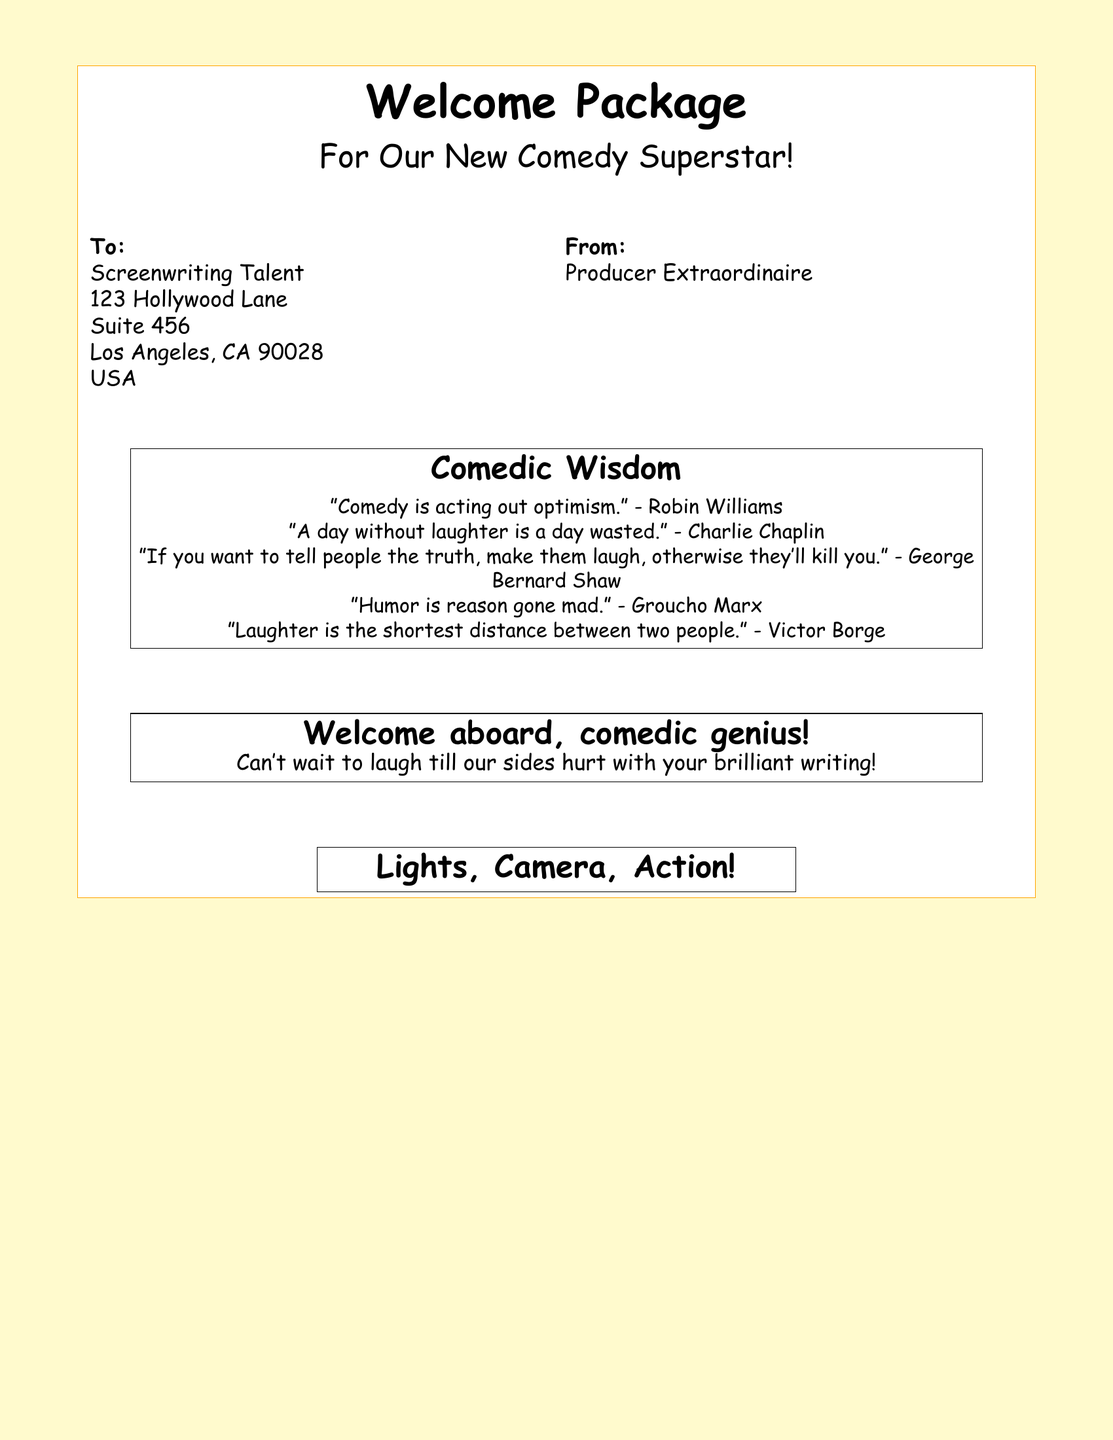What is the title on the shipping label? The title on the shipping label indicates the purpose of the package, which is "Welcome Package."
Answer: Welcome Package Who is the package addressed to? The label specifies the recipient as "Screenwriting Talent."
Answer: Screenwriting Talent Where is the recipient located? The address provided gives us the location details, including "123 Hollywood Lane, Suite 456, Los Angeles, CA 90028."
Answer: 123 Hollywood Lane, Suite 456, Los Angeles, CA 90028 Who is the sender of the package? The sender is identified as "Producer Extraordinaire."
Answer: Producer Extraordinaire How many quotes are included in the comedic wisdom section? The document lists five humorous quotes about comedy.
Answer: 5 What is the message in the welcome note? The note expresses excitement about the new writer's potential, saying they can't wait to laugh with the writer's talent.
Answer: Can't wait to laugh till our sides hurt with your brilliant writing! What visual element is included in the package design? The document features an illustration related to filmmaking, specifically a "clapperboard."
Answer: Clapperboard What color is the background of the shipping label? The background color used for the shipping label is a light yellow shade described as "labelcolor."
Answer: Light yellow What is the font used in the document? The document specifies the font as "Comic Sans MS."
Answer: Comic Sans MS 